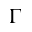<formula> <loc_0><loc_0><loc_500><loc_500>\Gamma</formula> 